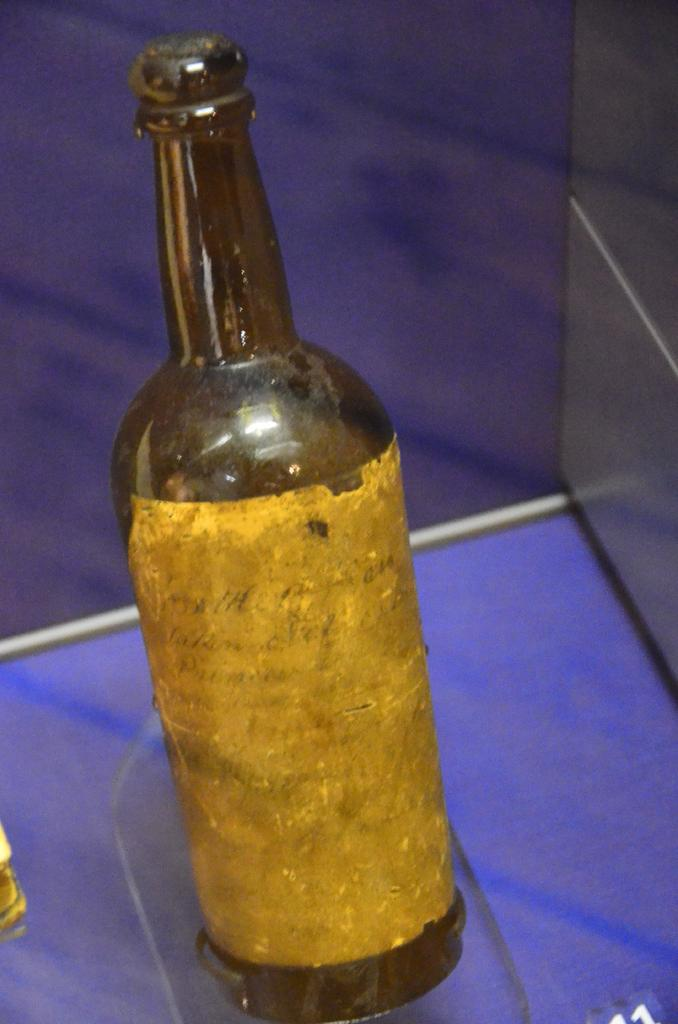What can be seen in the image that is typically used for holding liquids? There is a bottle in the image that is used for holding liquids. Where is the bottle located in the image? The bottle is on a platform in the image. What is attached to the bottle? There is a sticker on the bottle. What type of background can be seen in the image? There is a wall in the image. Is there any rain visible in the image? No, there is no rain visible in the image. What type of ornament is hanging from the ceiling in the image? There is no ornament hanging from the ceiling in the image. 